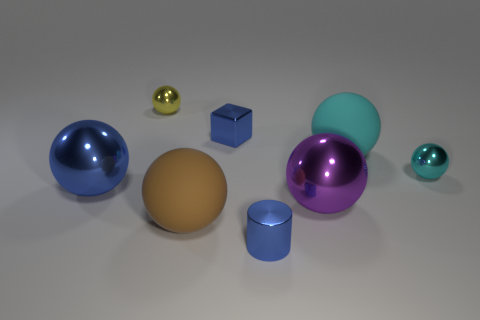What could the different sizes of spheres represent if this were a symbolic image? If this image were symbolic, the various sphere sizes could represent different planets or celestial bodies, or they might symbolize a hierarchy of concepts, with the larger spheres representing more significant ideas and the smaller ones more minor notions. Could you further elaborate on the concept of hierarchy in this context? Certainly, in a symbolic hierarchy, the largest matte sphere might represent a central authority or main idea, while the smaller, shiny spheres could signify lesser but supportive roles, each adding value and dimension to the structure implied by the arrangement. 